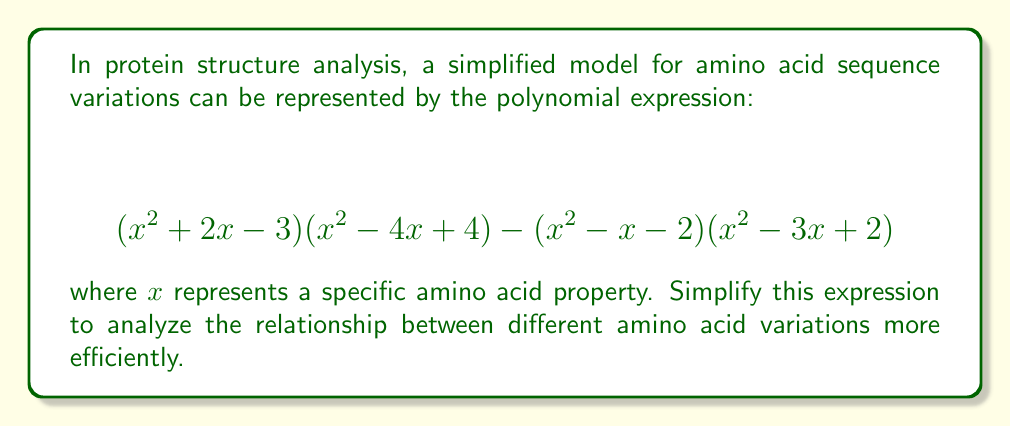Can you solve this math problem? Let's approach this step-by-step:

1) First, let's expand $(x^2 + 2x - 3)(x^2 - 4x + 4)$:
   $$(x^4 - 4x^3 + 4x^2) + (2x^3 - 8x^2 + 8x) + (-3x^2 + 12x - 12)$$
   $$= x^4 - 2x^3 - 7x^2 + 20x - 12$$

2) Now, let's expand $(x^2 - x - 2)(x^2 - 3x + 2)$:
   $$(x^4 - 3x^3 + 2x^2) + (-x^3 + 3x^2 - 2x) + (-2x^2 + 6x - 4)$$
   $$= x^4 - 4x^3 + 3x^2 + 4x - 4$$

3) Now we can subtract the second expansion from the first:
   $$(x^4 - 2x^3 - 7x^2 + 20x - 12) - (x^4 - 4x^3 + 3x^2 + 4x - 4)$$

4) Simplify by combining like terms:
   $$x^4 - 2x^3 - 7x^2 + 20x - 12 - x^4 + 4x^3 - 3x^2 - 4x + 4$$
   $$= 2x^3 - 10x^2 + 16x - 8$$

5) Factor out the greatest common factor:
   $$2(x^3 - 5x^2 + 8x - 4)$$

6) The cubic expression inside the parentheses can be factored further:
   $$2(x - 1)(x^2 - 4x + 4)$$

7) The quadratic term can be factored as a perfect square:
   $$2(x - 1)(x - 2)^2$$

This final form represents the simplified expression modeling amino acid sequence variations.
Answer: $2(x - 1)(x - 2)^2$ 